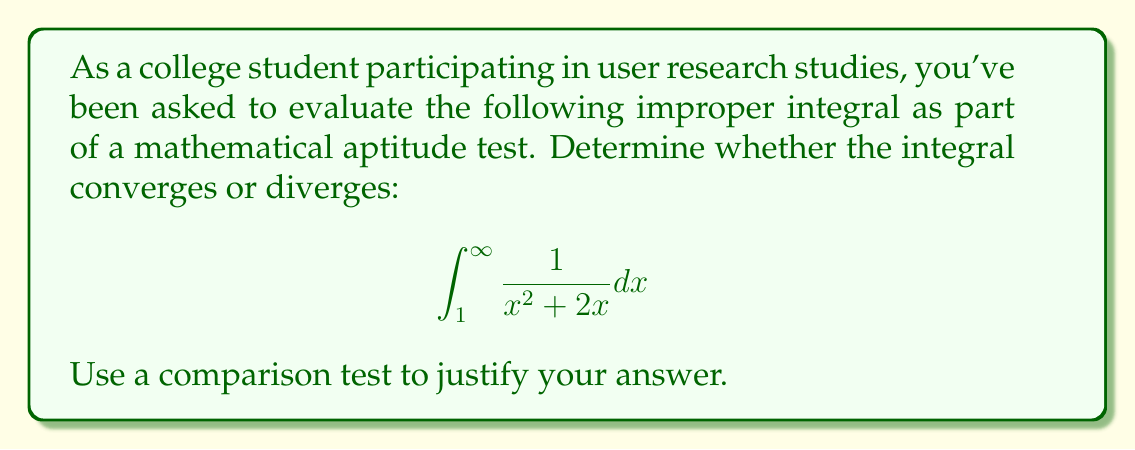Teach me how to tackle this problem. Let's approach this step-by-step:

1) First, we need to consider the behavior of the integrand as $x$ approaches infinity. We can see that:

   $$\lim_{x \to \infty} \frac{1}{x^2 + 2x} = 0$$

   This suggests that the integral might converge, but we need to prove it.

2) To use a comparison test, we need to find a simpler function that's always greater than or equal to our integrand, but still integrable.

3) Let's consider the inequality:
   
   For $x \geq 1$, $x^2 + 2x > x^2$

4) Therefore:

   $$\frac{1}{x^2 + 2x} < \frac{1}{x^2}$$

5) This means we can compare our integral to:

   $$\int_1^{\infty} \frac{1}{x^2} dx$$

6) We know that $\int_1^{\infty} \frac{1}{x^2} dx$ converges (it's a p-integral with $p=2 > 1$).

7) Specifically:

   $$\int_1^{\infty} \frac{1}{x^2} dx = [-\frac{1}{x}]_1^{\infty} = 0 - (-1) = 1$$

8) By the comparison test, since $\frac{1}{x^2 + 2x} < \frac{1}{x^2}$ for $x \geq 1$, and $\int_1^{\infty} \frac{1}{x^2} dx$ converges, our original integral must also converge.
Answer: The improper integral $\int_1^{\infty} \frac{1}{x^2 + 2x} dx$ converges. 